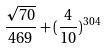<formula> <loc_0><loc_0><loc_500><loc_500>\frac { \sqrt { 7 0 } } { 4 6 9 } + ( \frac { 4 } { 1 0 } ) ^ { 3 0 4 }</formula> 